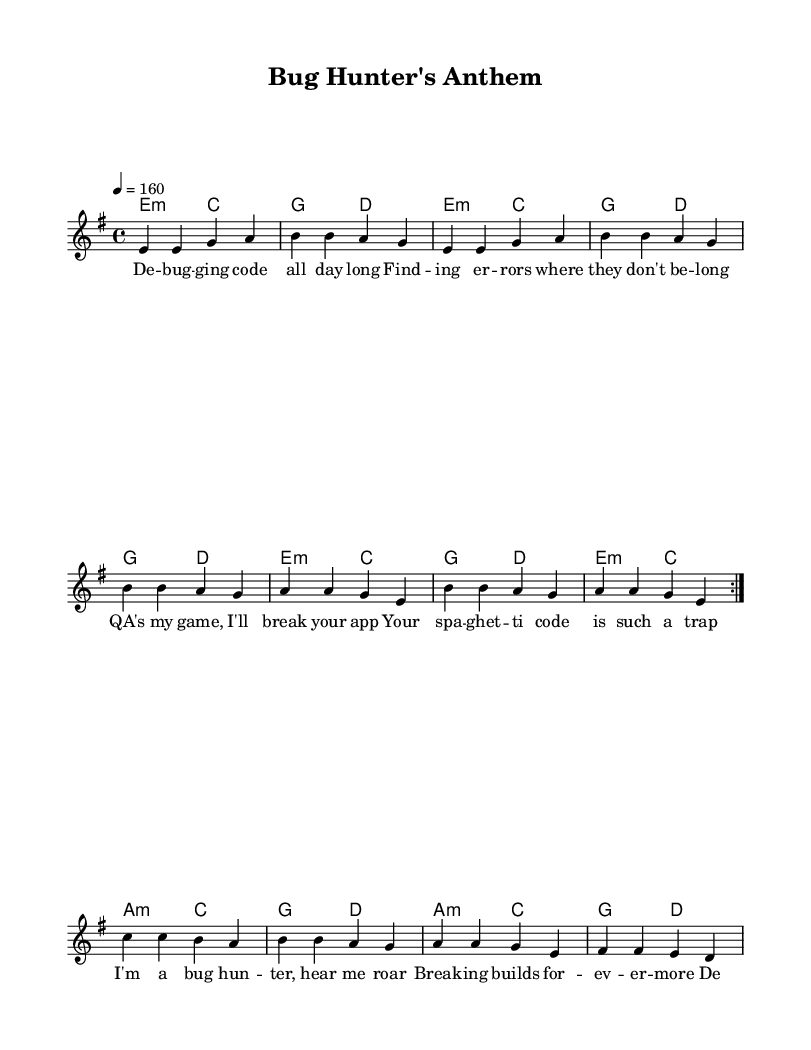What is the key signature of this music? The key signature is E minor, which has one sharp (F#). The key signature is identified at the beginning of the piece, indicated by the sharp symbol placed on the F line of the staff.
Answer: E minor What is the time signature of this music? The time signature is 4/4, which is evident at the beginning of the staff where it shows how many beats are in each measure and what note value gets the beat. This means there are four quarter notes per measure.
Answer: 4/4 What is the tempo marking for this piece? The tempo marking is 4 = 160, which is found at the beginning of the score. It indicates that the quarter note should be played at a rate of 160 beats per minute.
Answer: 160 How many repetitions are indicated for the main melody section? The main melody section has a repeat indication "volta 2," which shows that this section should be played twice. This is part of the layout of the melody where the musical notation indicates the number of times to repeat certain measures.
Answer: 2 What genre is this song classified as? The song is classified as Punk, evident from the lyrics, thematic content in the verses and chorus, and the upbeat, energetic feel of the piece, which aligns with the characteristics of punk music.
Answer: Punk What is the function of the lyrics in this piece? The lyrics provide a clear satirical commentary on software testing, drawing humor from the challenges faced by software testers in the tech environment. They support the song's theme by describing the experiences and stereotypes of QA professionals.
Answer: Commentary How many verses are present in this song? There is one verse followed by a chorus in this composition. The verse captures the essence of the subject matter, while the chorus emphasizes the message and serves as a repeated refrain.
Answer: 1 